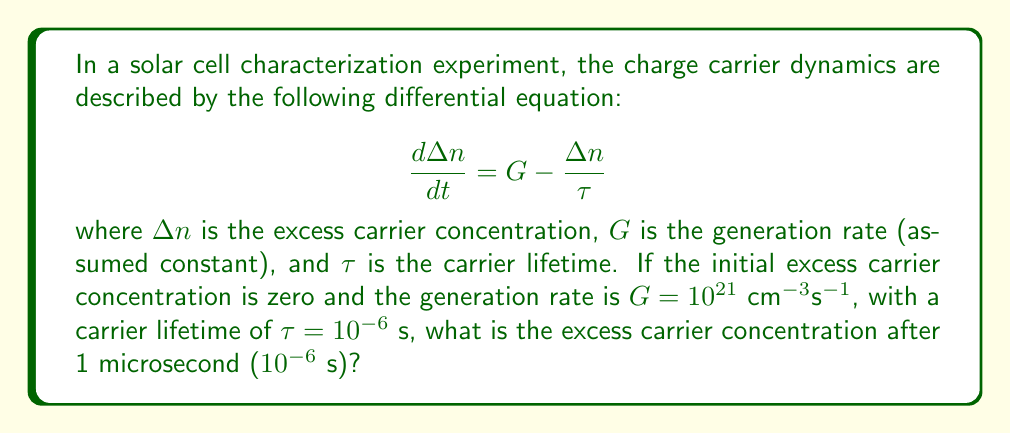What is the answer to this math problem? To solve this problem, we need to follow these steps:

1) The given differential equation is a first-order linear differential equation:

   $$\frac{d\Delta n}{dt} = G - \frac{\Delta n}{\tau}$$

2) The general solution for this type of equation is:

   $$\Delta n(t) = G\tau(1 - e^{-t/\tau}) + \Delta n(0)e^{-t/\tau}$$

3) We're given the following parameters:
   - $G = 10^{21}$ cm$^{-3}$s$^{-1}$
   - $\tau = 10^{-6}$ s
   - $\Delta n(0) = 0$ (initial excess carrier concentration)
   - $t = 10^{-6}$ s (time we're interested in)

4) Substituting these values into our solution:

   $$\Delta n(10^{-6}) = 10^{21} \cdot 10^{-6} \cdot (1 - e^{-10^{-6}/10^{-6}}) + 0 \cdot e^{-10^{-6}/10^{-6}}$$

5) Simplify:
   
   $$\Delta n(10^{-6}) = 10^{15} \cdot (1 - e^{-1})$$

6) Calculate:
   
   $$\Delta n(10^{-6}) = 10^{15} \cdot (1 - 0.3679) = 6.321 \times 10^{14}$$ cm$^{-3}$

Therefore, after 1 microsecond, the excess carrier concentration is approximately $6.321 \times 10^{14}$ cm$^{-3}$.
Answer: $6.321 \times 10^{14}$ cm$^{-3}$ 